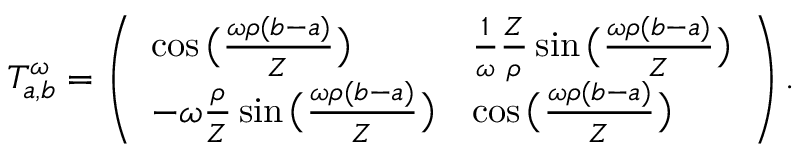<formula> <loc_0><loc_0><loc_500><loc_500>T _ { a , b } ^ { \omega } = \left ( \begin{array} { l l } { \cos \left ( \frac { \omega \rho ( b - a ) } { Z } \right ) } & { \frac { 1 } { \omega } \frac { Z } { \rho } \sin \left ( \frac { \omega \rho ( b - a ) } { Z } \right ) } \\ { - \omega \frac { \rho } { Z } \sin \left ( \frac { \omega \rho ( b - a ) } { Z } \right ) } & { \cos \left ( \frac { \omega \rho ( b - a ) } { Z } \right ) } \end{array} \right ) .</formula> 